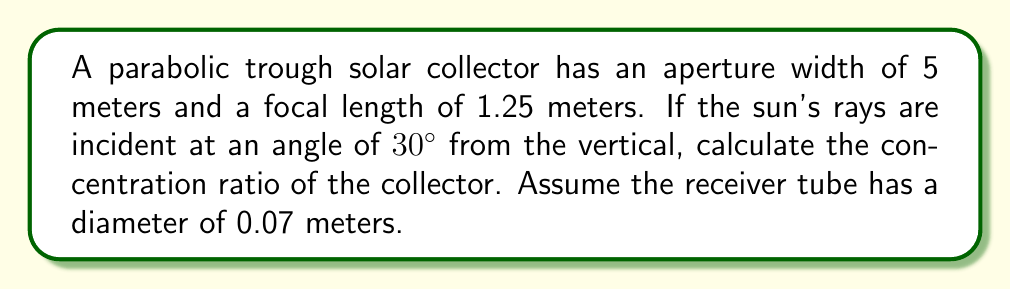Could you help me with this problem? To solve this problem, we'll follow these steps:

1) First, we need to understand what the concentration ratio is. It's the ratio of the aperture area to the receiver area.

2) The aperture area is simply the width of the trough multiplied by its length. Since we're only given the width, we'll assume a unit length of 1 meter.

   Aperture area = $5 \text{ m} \times 1 \text{ m} = 5 \text{ m}^2$

3) The receiver area is the surface area of the receiver tube that's exposed to the concentrated sunlight. This is approximately the diameter of the tube multiplied by the unit length.

   Receiver area = $0.07 \text{ m} \times 1 \text{ m} = 0.07 \text{ m}^2$

4) However, we need to account for the incident angle of the sun's rays. The effective aperture width is reduced by the cosine of the incident angle:

   Effective aperture width = $5 \text{ m} \times \cos(30°) = 5 \text{ m} \times \frac{\sqrt{3}}{2} \approx 4.33 \text{ m}$

5) The new aperture area is:

   Effective aperture area = $4.33 \text{ m} \times 1 \text{ m} = 4.33 \text{ m}^2$

6) Now we can calculate the concentration ratio:

   Concentration ratio = $\frac{\text{Effective aperture area}}{\text{Receiver area}} = \frac{4.33 \text{ m}^2}{0.07 \text{ m}^2} \approx 61.86$

Therefore, the concentration ratio is approximately 61.86.

[asy]
import geometry;

size(200);

pair A = (-2.5,0), B = (2.5,0), C = (0,1.25);
path p = parabola(A,C,B);

draw(p);
draw(A--B,arrow=Arrow(TeXHead));
draw(C--C+(0,-1.25),arrow=Arrow(TeXHead));

label("5 m", (0,-0.2), S);
label("1.25 m", (2.7,0.625), E);

pair D = (2.165,0.866);
draw(D--(D.x,0),dashed);
draw((-3,1.732)--(3,1.732),arrow=Arrow(TeXHead));
draw((2.165,1.732)--(2.165,0),arrow=Arrow(TeXHead));

label("30°", (2.3,0.3), NE);
label("Sun rays", (-2.5,1.9), N);

dot("Focal point", C, N);
[/asy]
Answer: The concentration ratio of the parabolic trough solar collector is approximately 61.86. 